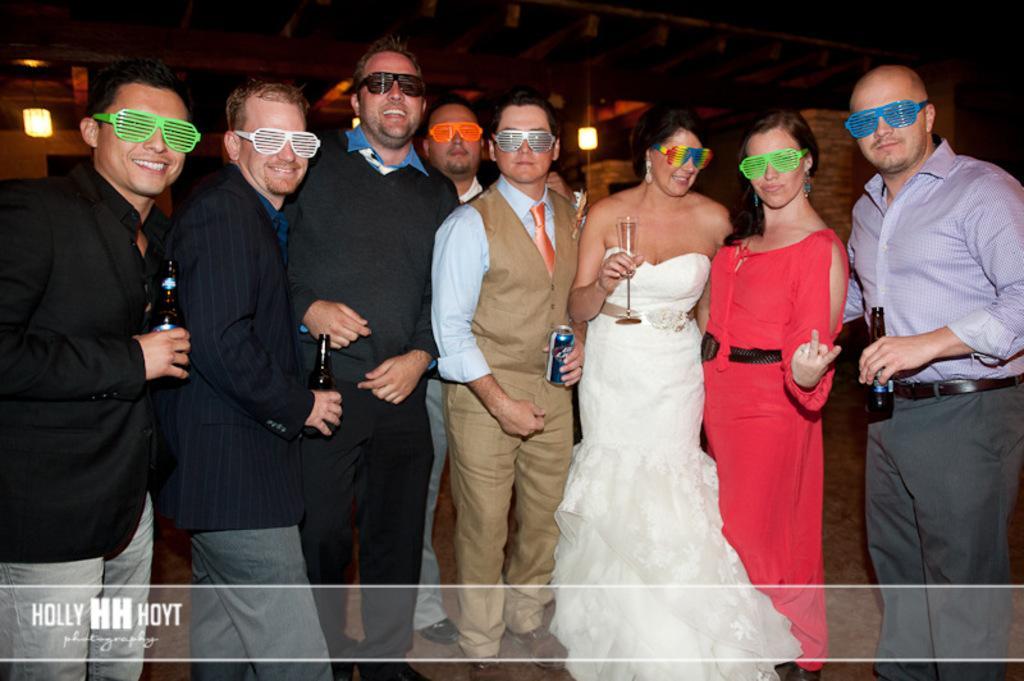Describe this image in one or two sentences. In this picture we can see a group of people,they are wearing spectacles and in the background we can see lights. 